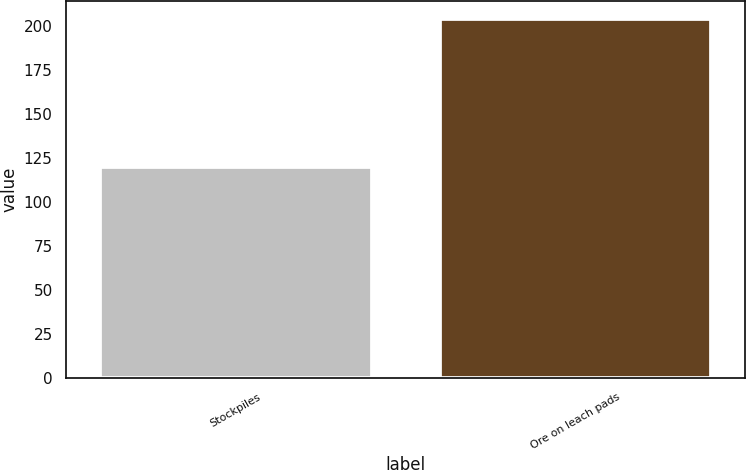Convert chart to OTSL. <chart><loc_0><loc_0><loc_500><loc_500><bar_chart><fcel>Stockpiles<fcel>Ore on leach pads<nl><fcel>120<fcel>204<nl></chart> 